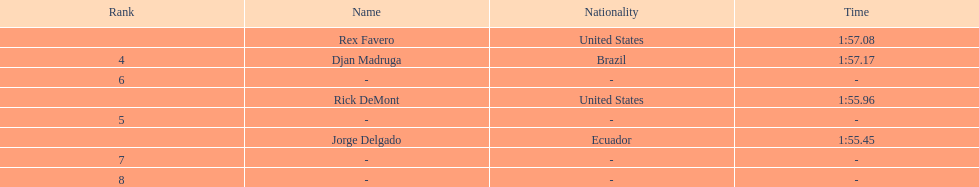How many ranked swimmers were from the united states? 2. 